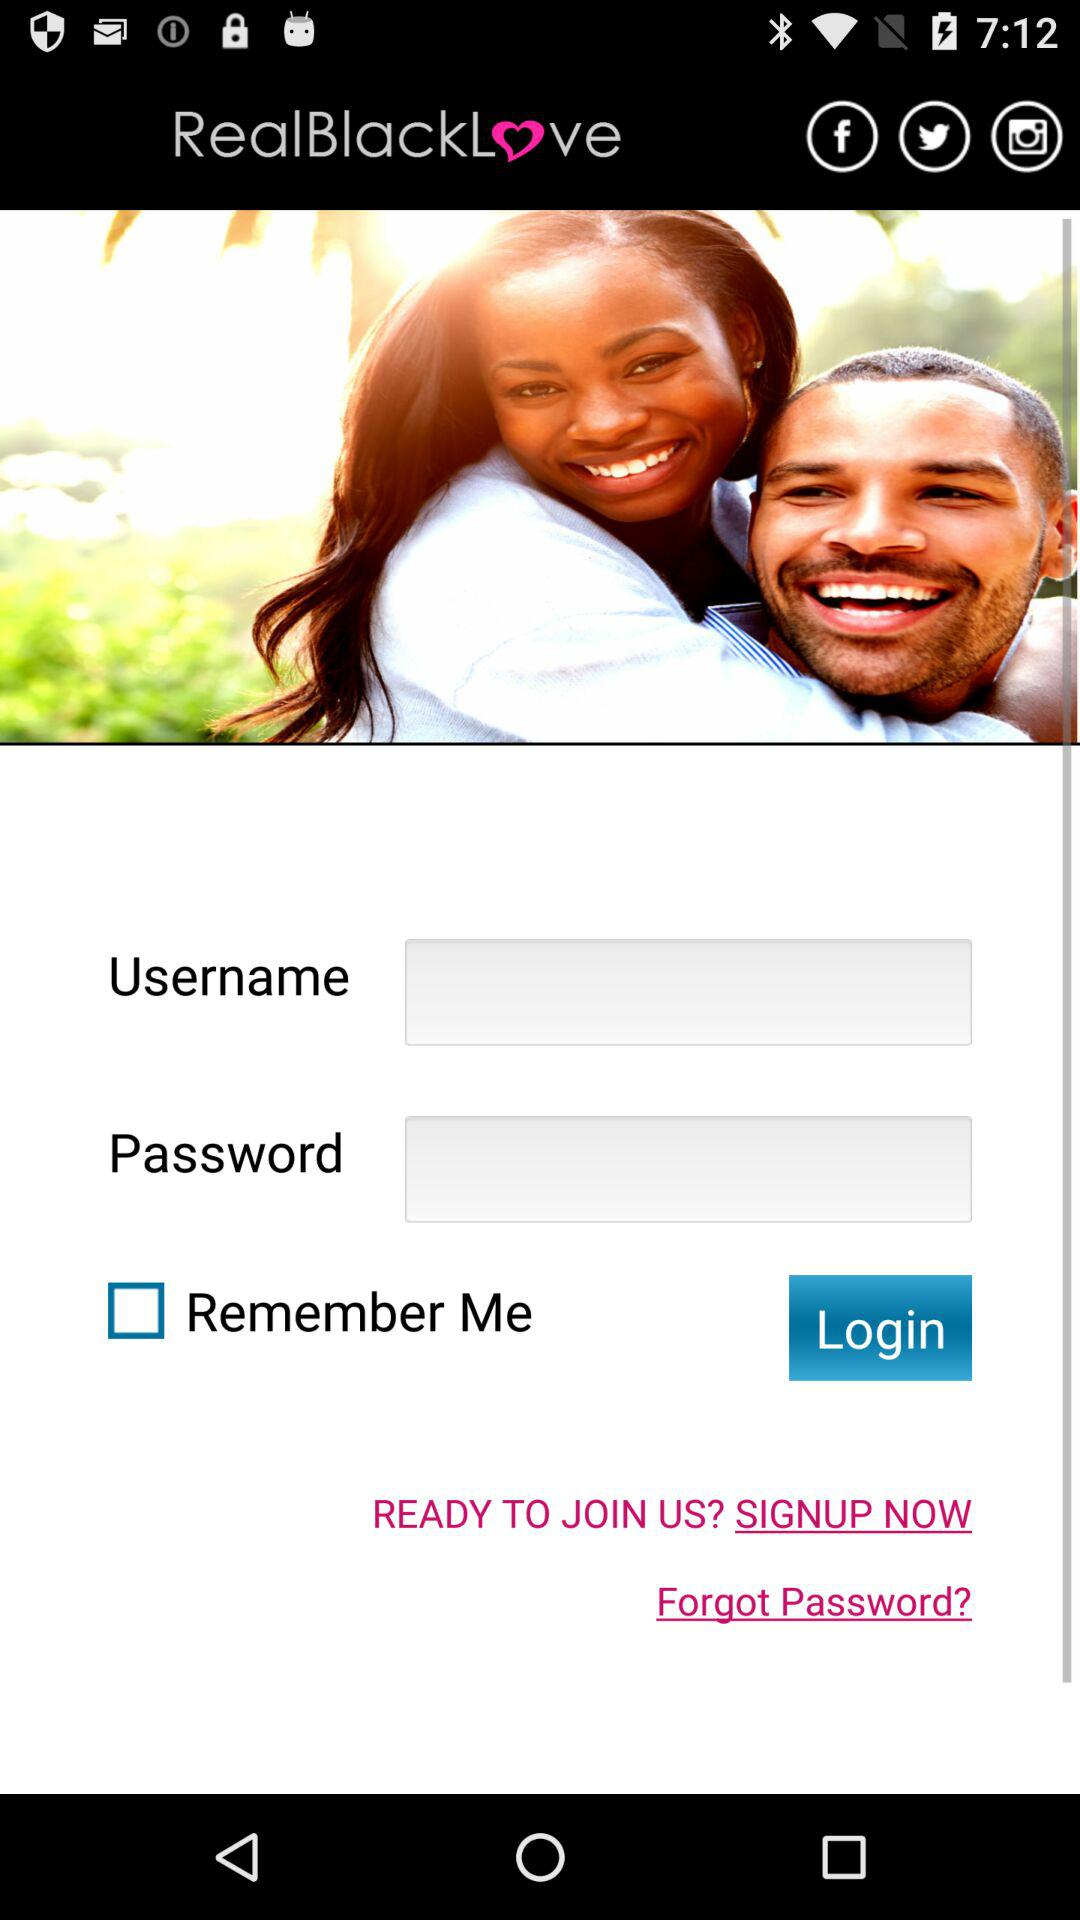What is the app name? The app name is "RealBlackLove". 